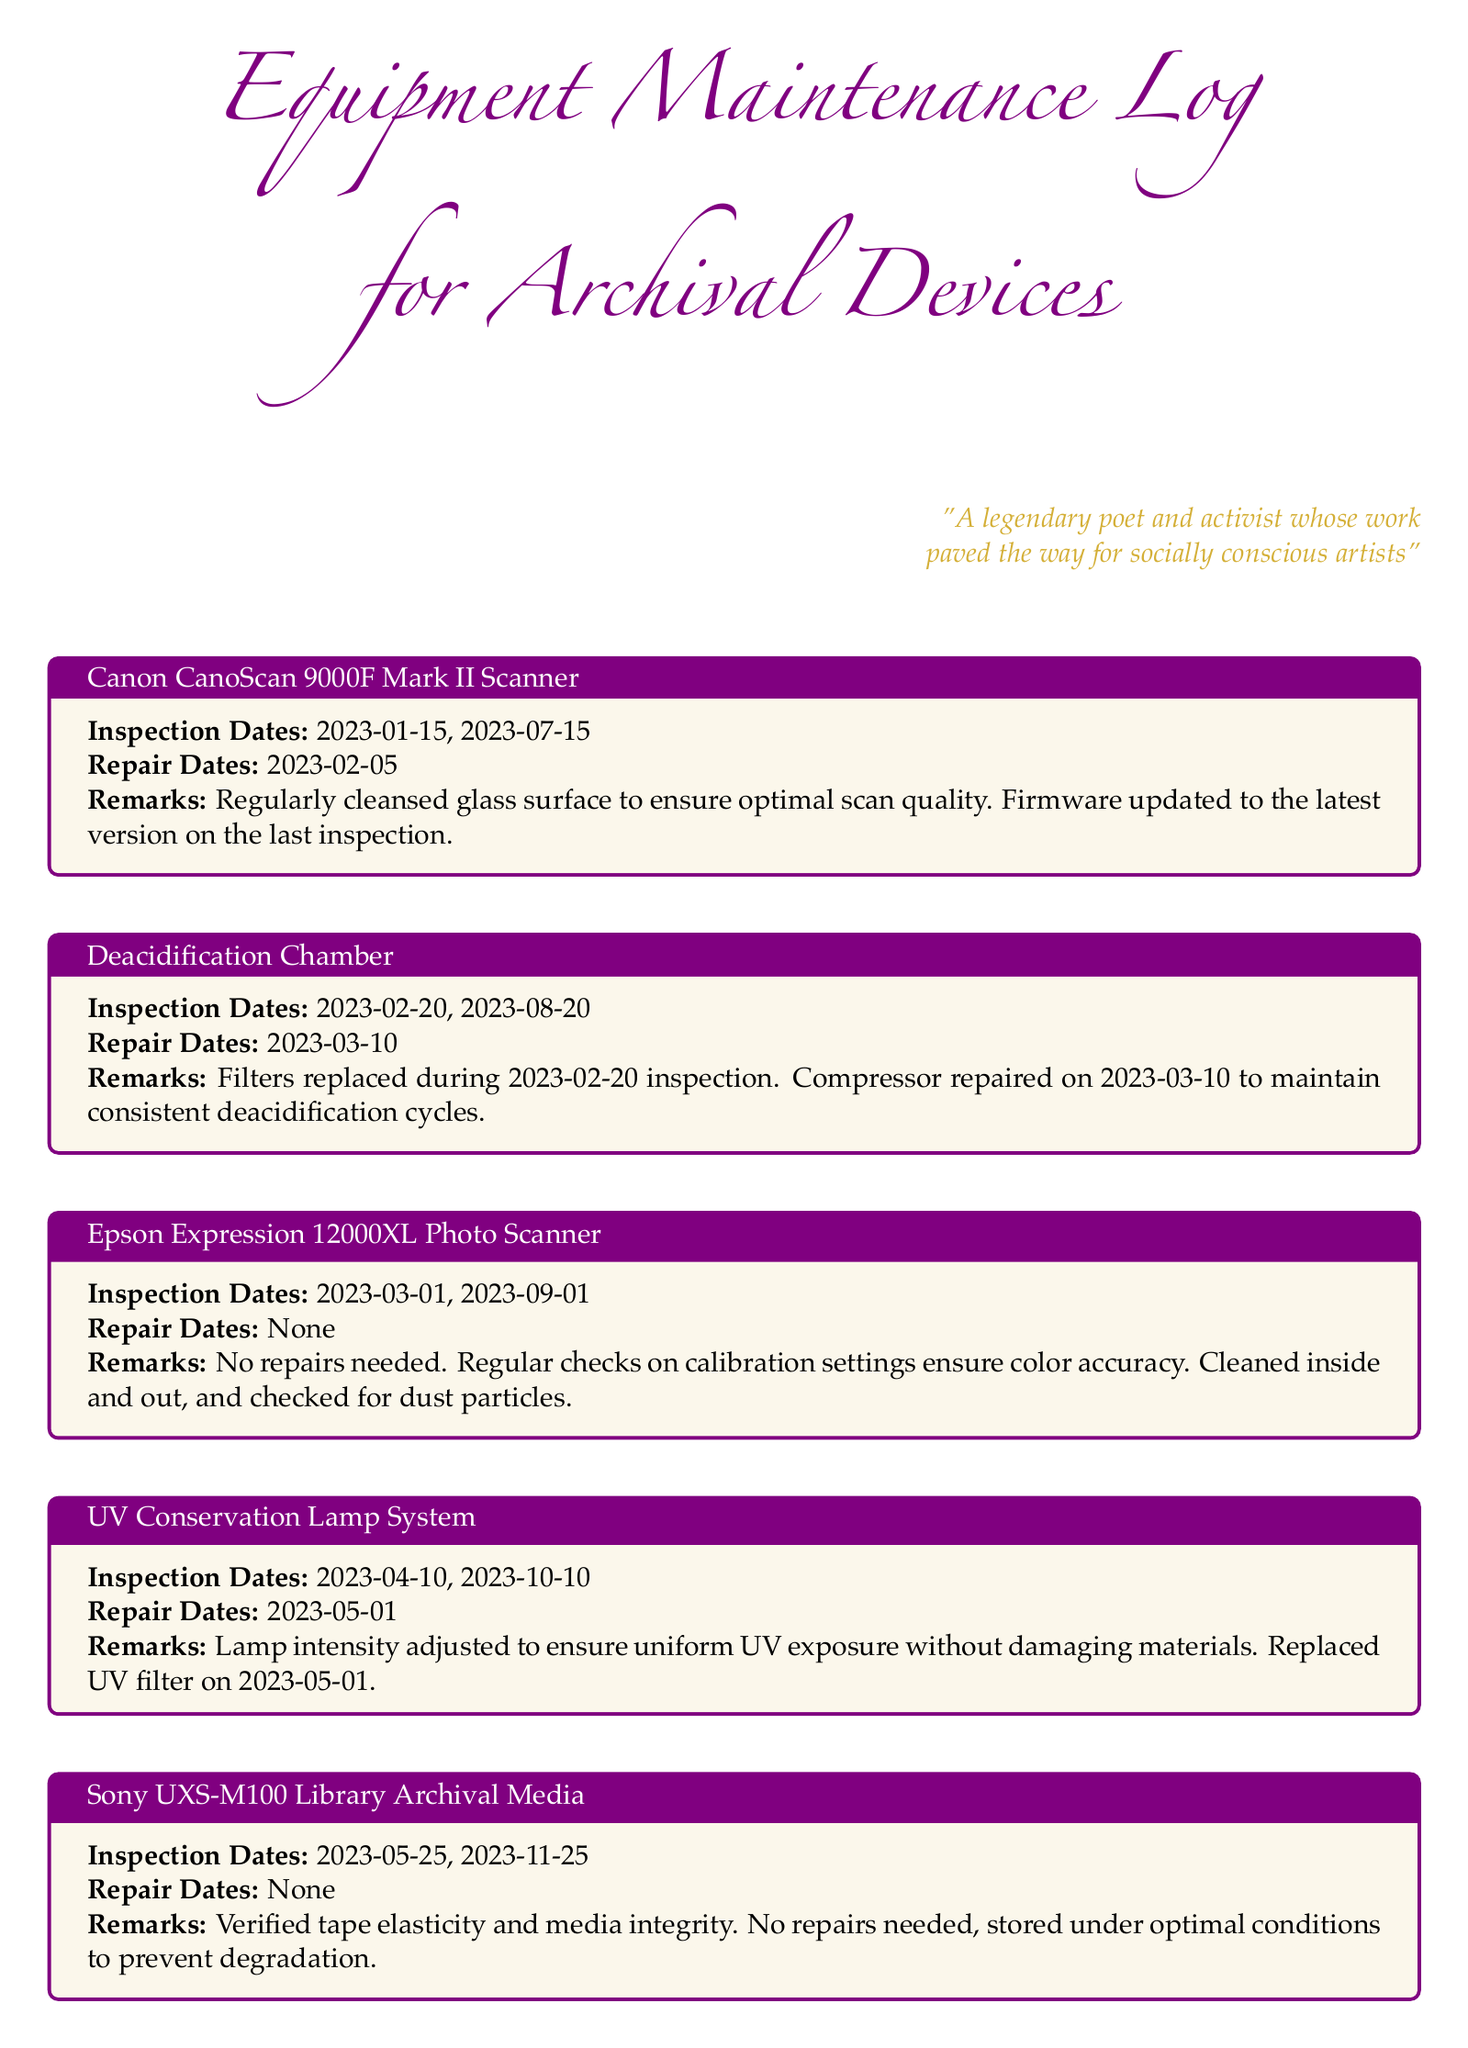What are the inspection dates for the Canon CanoScan 9000F Mark II Scanner? The inspection dates are specifically listed under the Canon CanoScan 9000F Mark II Scanner section, which includes 2023-01-15 and 2023-07-15.
Answer: 2023-01-15, 2023-07-15 When was the Deacidification Chamber repaired? The repair date is specified directly in the Deacidification Chamber section, which states it was repaired on 2023-03-10.
Answer: 2023-03-10 How many inspection dates does the Epson Expression 12000XL Photo Scanner have? The number of inspection dates is found in the respective section, which lists a total of two inspection dates: 2023-03-01 and 2023-09-01.
Answer: 2 What maintenance action was performed on the UV Conservation Lamp System on 2023-05-01? The log clearly states that the UV filter was replaced on this specific date.
Answer: Replaced UV filter Which equipment had no repair dates listed? The equipment sections show that both the Epson Expression 12000XL Photo Scanner and the Sony UXS-M100 Library Archival Media had no repair dates mentioned.
Answer: Epson Expression 12000XL Photo Scanner, Sony UXS-M100 Library Archival Media What was adjusted during the inspection of the UV Conservation Lamp System? The remarks for the UV Conservation Lamp System mention that the lamp intensity was adjusted to ensure uniform UV exposure.
Answer: Lamp intensity adjusted 